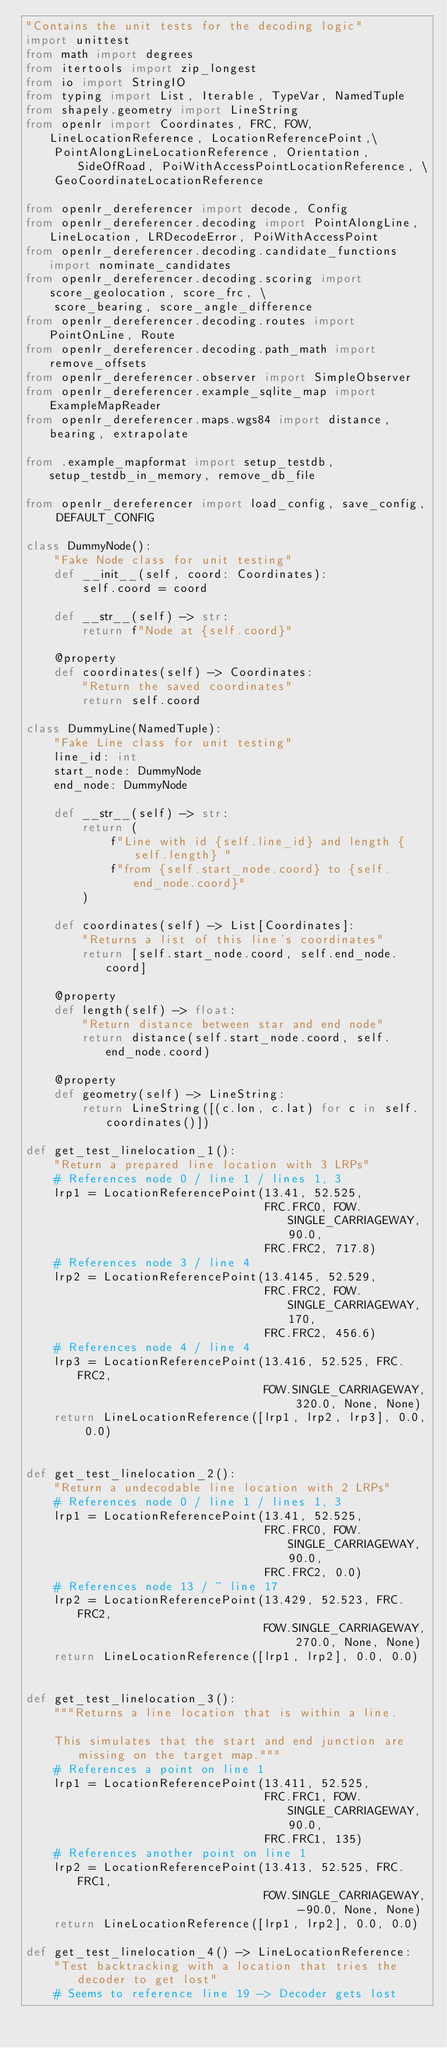<code> <loc_0><loc_0><loc_500><loc_500><_Python_>"Contains the unit tests for the decoding logic"
import unittest
from math import degrees
from itertools import zip_longest
from io import StringIO
from typing import List, Iterable, TypeVar, NamedTuple
from shapely.geometry import LineString
from openlr import Coordinates, FRC, FOW, LineLocationReference, LocationReferencePoint,\
    PointAlongLineLocationReference, Orientation, SideOfRoad, PoiWithAccessPointLocationReference, \
    GeoCoordinateLocationReference

from openlr_dereferencer import decode, Config
from openlr_dereferencer.decoding import PointAlongLine, LineLocation, LRDecodeError, PoiWithAccessPoint
from openlr_dereferencer.decoding.candidate_functions import nominate_candidates
from openlr_dereferencer.decoding.scoring import score_geolocation, score_frc, \
    score_bearing, score_angle_difference
from openlr_dereferencer.decoding.routes import PointOnLine, Route
from openlr_dereferencer.decoding.path_math import remove_offsets
from openlr_dereferencer.observer import SimpleObserver
from openlr_dereferencer.example_sqlite_map import ExampleMapReader
from openlr_dereferencer.maps.wgs84 import distance, bearing, extrapolate

from .example_mapformat import setup_testdb, setup_testdb_in_memory, remove_db_file

from openlr_dereferencer import load_config, save_config, DEFAULT_CONFIG

class DummyNode():
    "Fake Node class for unit testing"
    def __init__(self, coord: Coordinates):
        self.coord = coord

    def __str__(self) -> str:
        return f"Node at {self.coord}"

    @property
    def coordinates(self) -> Coordinates:
        "Return the saved coordinates"
        return self.coord

class DummyLine(NamedTuple):
    "Fake Line class for unit testing"
    line_id: int
    start_node: DummyNode
    end_node: DummyNode

    def __str__(self) -> str:
        return (
            f"Line with id {self.line_id} and length {self.length} "
            f"from {self.start_node.coord} to {self.end_node.coord}"
        )

    def coordinates(self) -> List[Coordinates]:
        "Returns a list of this line's coordinates"
        return [self.start_node.coord, self.end_node.coord]

    @property
    def length(self) -> float:
        "Return distance between star and end node"
        return distance(self.start_node.coord, self.end_node.coord)

    @property
    def geometry(self) -> LineString:
        return LineString([(c.lon, c.lat) for c in self.coordinates()])

def get_test_linelocation_1():
    "Return a prepared line location with 3 LRPs"
    # References node 0 / line 1 / lines 1, 3
    lrp1 = LocationReferencePoint(13.41, 52.525,
                                  FRC.FRC0, FOW.SINGLE_CARRIAGEWAY, 90.0,
                                  FRC.FRC2, 717.8)
    # References node 3 / line 4
    lrp2 = LocationReferencePoint(13.4145, 52.529,
                                  FRC.FRC2, FOW.SINGLE_CARRIAGEWAY, 170,
                                  FRC.FRC2, 456.6)
    # References node 4 / line 4
    lrp3 = LocationReferencePoint(13.416, 52.525, FRC.FRC2,
                                  FOW.SINGLE_CARRIAGEWAY, 320.0, None, None)
    return LineLocationReference([lrp1, lrp2, lrp3], 0.0, 0.0)


def get_test_linelocation_2():
    "Return a undecodable line location with 2 LRPs"
    # References node 0 / line 1 / lines 1, 3
    lrp1 = LocationReferencePoint(13.41, 52.525,
                                  FRC.FRC0, FOW.SINGLE_CARRIAGEWAY, 90.0,
                                  FRC.FRC2, 0.0)
    # References node 13 / ~ line 17
    lrp2 = LocationReferencePoint(13.429, 52.523, FRC.FRC2,
                                  FOW.SINGLE_CARRIAGEWAY, 270.0, None, None)
    return LineLocationReference([lrp1, lrp2], 0.0, 0.0)


def get_test_linelocation_3():
    """Returns a line location that is within a line.
    
    This simulates that the start and end junction are missing on the target map."""
    # References a point on line 1
    lrp1 = LocationReferencePoint(13.411, 52.525,
                                  FRC.FRC1, FOW.SINGLE_CARRIAGEWAY, 90.0,
                                  FRC.FRC1, 135)
    # References another point on line 1
    lrp2 = LocationReferencePoint(13.413, 52.525, FRC.FRC1,
                                  FOW.SINGLE_CARRIAGEWAY, -90.0, None, None)
    return LineLocationReference([lrp1, lrp2], 0.0, 0.0)

def get_test_linelocation_4() -> LineLocationReference:
    "Test backtracking with a location that tries the decoder to get lost"
    # Seems to reference line 19 -> Decoder gets lost</code> 